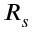<formula> <loc_0><loc_0><loc_500><loc_500>R _ { s }</formula> 